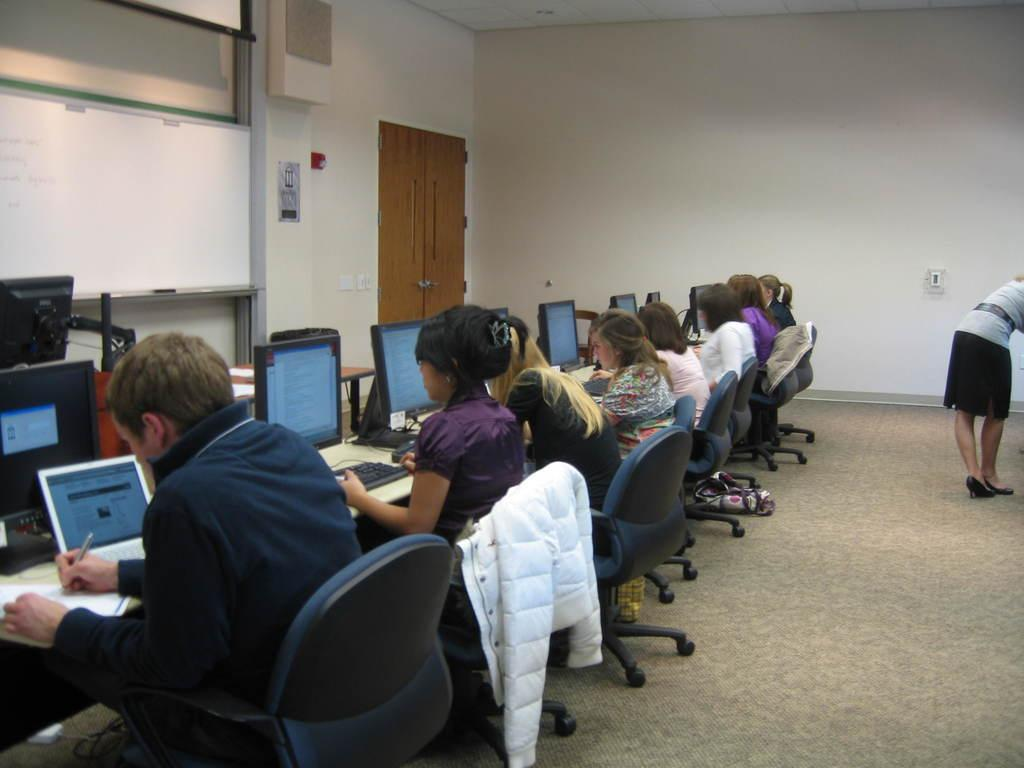What is happening in the middle of the image? There is a group of people sitting in the middle of the image. What are the people sitting on? The people are sitting on chairs. What activity are the people engaged in? The people are working with systems. Can you describe the person on the right side of the image? There is a person standing on the right side of the image. What type of environment is depicted in the image? The setting appears to be an office. How many cushions are on the chairs in the image? There is no mention of cushions on the chairs in the image. Can you tell me how many frogs are hopping around in the office? There are no frogs present in the image; it depicts a group of people working in an office setting. 